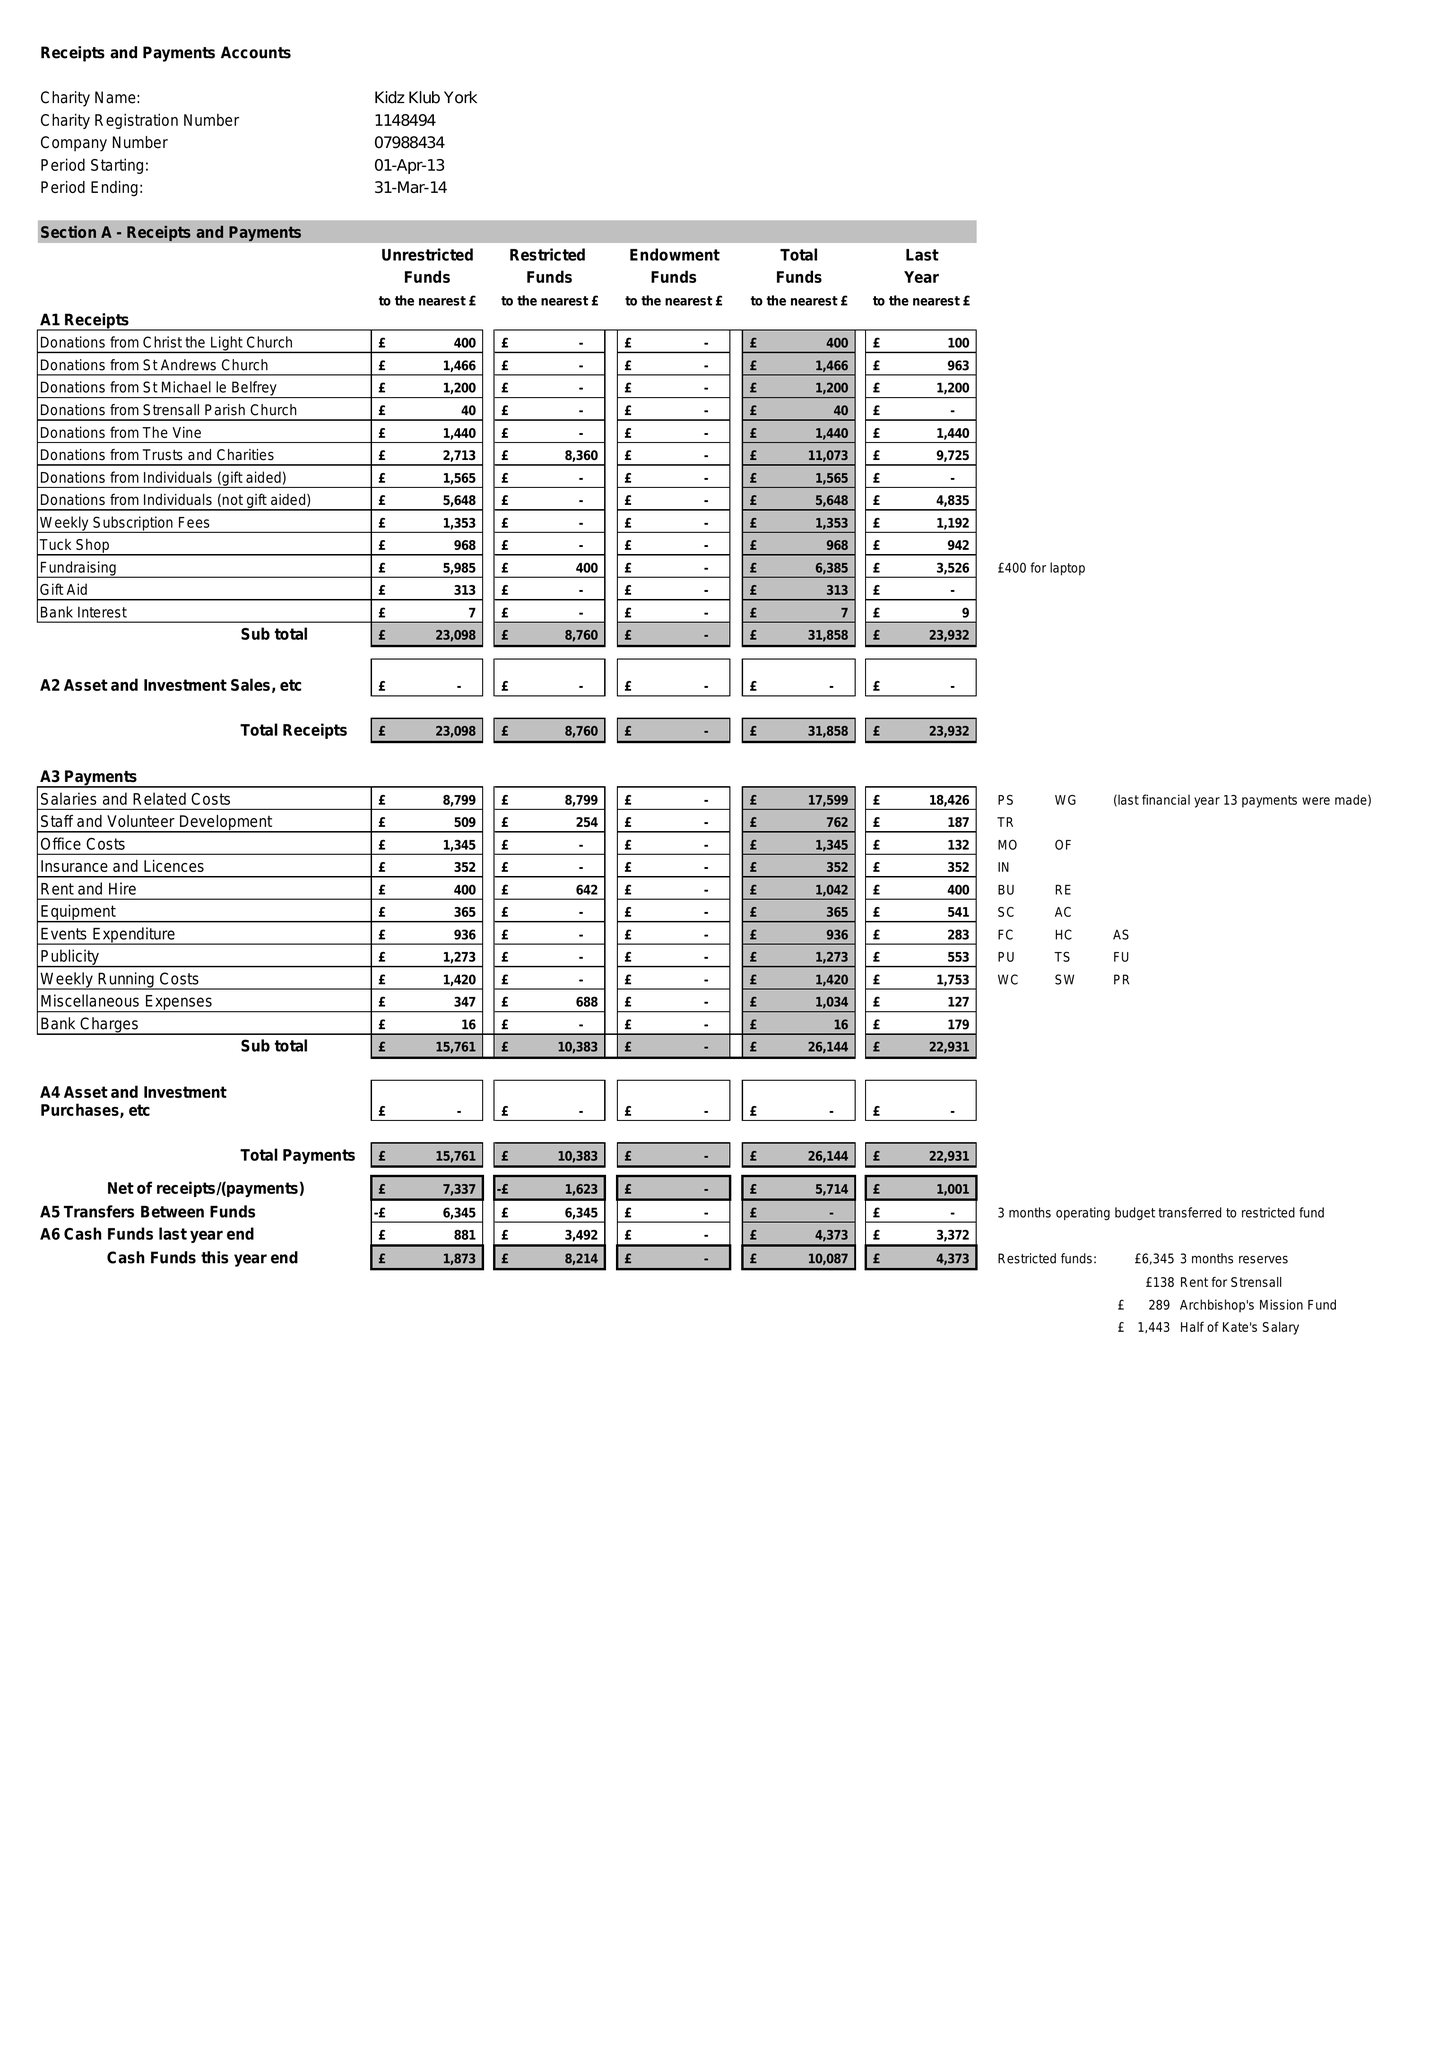What is the value for the address__postcode?
Answer the question using a single word or phrase. YO32 9PX 